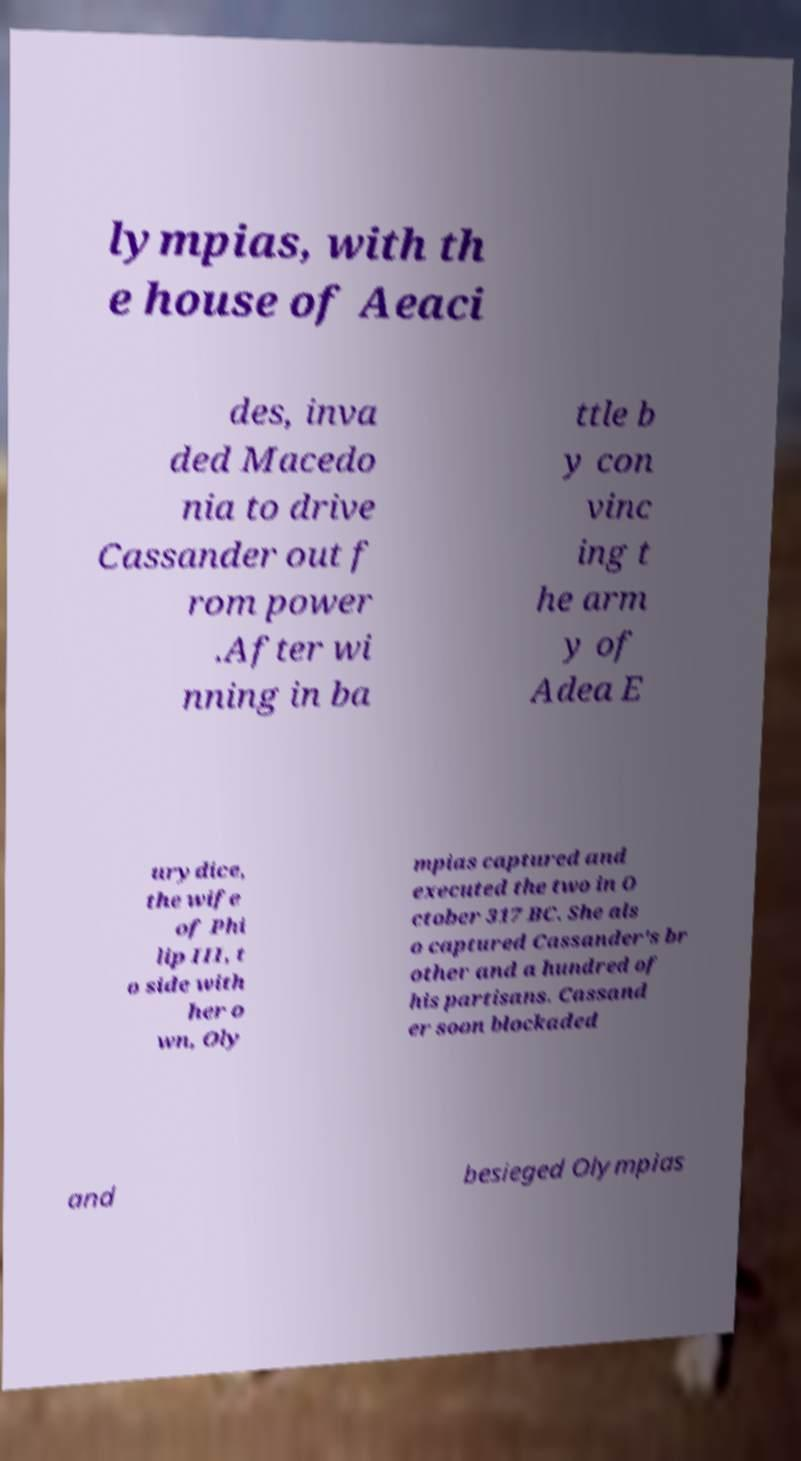For documentation purposes, I need the text within this image transcribed. Could you provide that? lympias, with th e house of Aeaci des, inva ded Macedo nia to drive Cassander out f rom power .After wi nning in ba ttle b y con vinc ing t he arm y of Adea E urydice, the wife of Phi lip III, t o side with her o wn, Oly mpias captured and executed the two in O ctober 317 BC. She als o captured Cassander's br other and a hundred of his partisans. Cassand er soon blockaded and besieged Olympias 